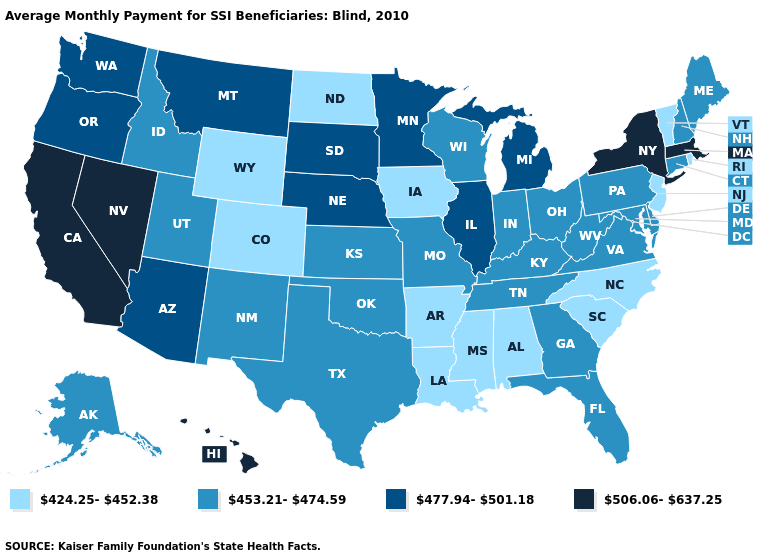Does the map have missing data?
Give a very brief answer. No. Among the states that border Utah , does Nevada have the highest value?
Keep it brief. Yes. What is the lowest value in states that border Nevada?
Keep it brief. 453.21-474.59. Name the states that have a value in the range 424.25-452.38?
Quick response, please. Alabama, Arkansas, Colorado, Iowa, Louisiana, Mississippi, New Jersey, North Carolina, North Dakota, Rhode Island, South Carolina, Vermont, Wyoming. Which states have the lowest value in the MidWest?
Quick response, please. Iowa, North Dakota. Does Pennsylvania have the highest value in the Northeast?
Concise answer only. No. Which states have the highest value in the USA?
Be succinct. California, Hawaii, Massachusetts, Nevada, New York. Does Wisconsin have the lowest value in the USA?
Short answer required. No. What is the value of Mississippi?
Answer briefly. 424.25-452.38. Which states have the lowest value in the West?
Give a very brief answer. Colorado, Wyoming. Does the first symbol in the legend represent the smallest category?
Concise answer only. Yes. What is the value of Pennsylvania?
Give a very brief answer. 453.21-474.59. Which states have the lowest value in the South?
Be succinct. Alabama, Arkansas, Louisiana, Mississippi, North Carolina, South Carolina. What is the value of West Virginia?
Answer briefly. 453.21-474.59. Name the states that have a value in the range 477.94-501.18?
Quick response, please. Arizona, Illinois, Michigan, Minnesota, Montana, Nebraska, Oregon, South Dakota, Washington. 